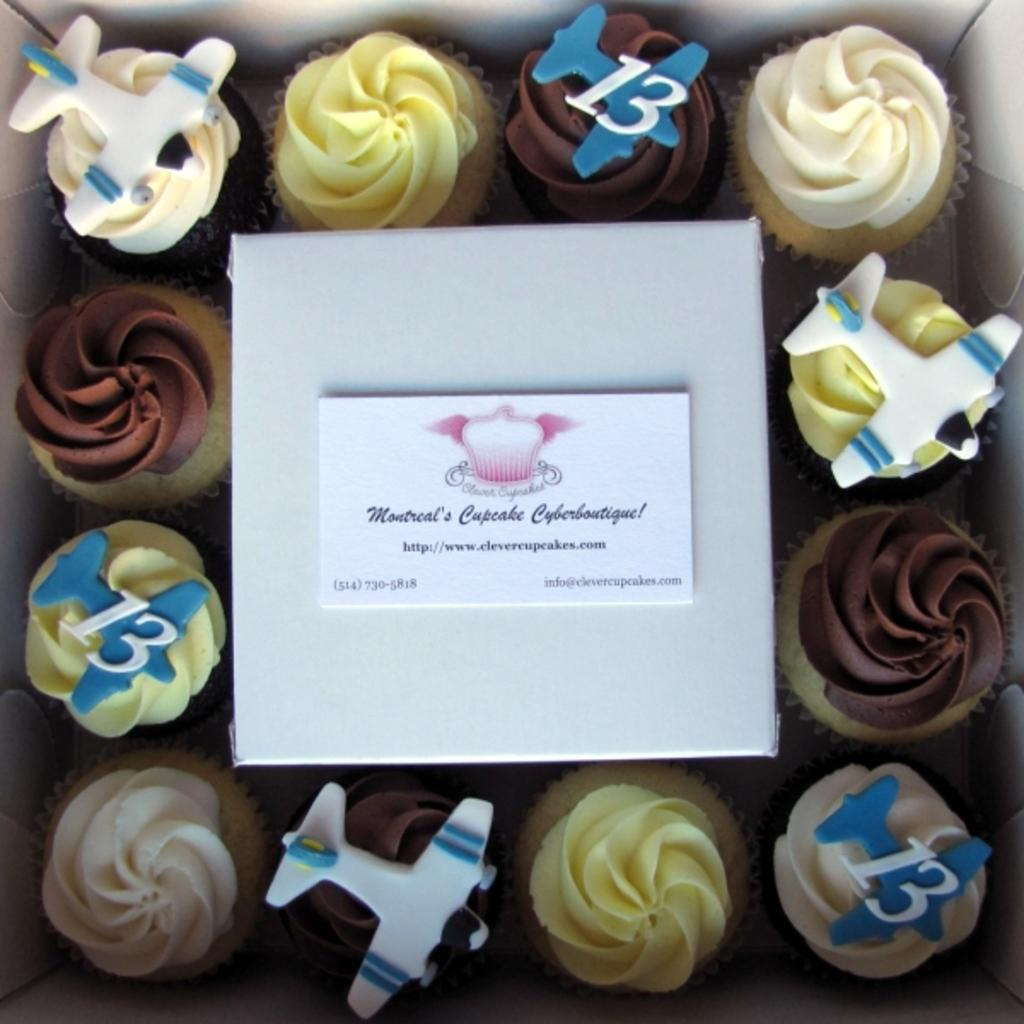What is the main subject of the image? There is a food item in the image. What else can be seen in the image besides the food item? There is a card with some text in the image. What type of cap is the ant wearing in the image? There is no ant or cap present in the image. How many eggs are visible in the image? There are no eggs present in the image. 